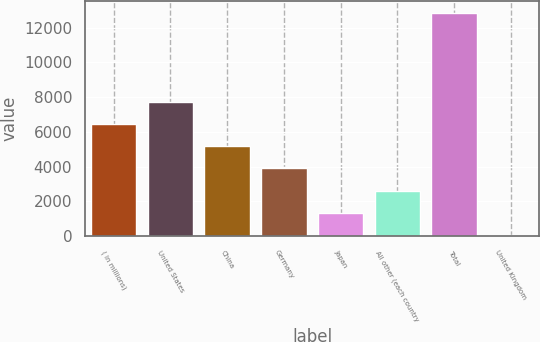Convert chart to OTSL. <chart><loc_0><loc_0><loc_500><loc_500><bar_chart><fcel>( in millions)<fcel>United States<fcel>China<fcel>Germany<fcel>Japan<fcel>All other (each country<fcel>Total<fcel>United Kingdom<nl><fcel>6462.1<fcel>7743.06<fcel>5181.14<fcel>3900.18<fcel>1338.26<fcel>2619.22<fcel>12866.9<fcel>57.3<nl></chart> 